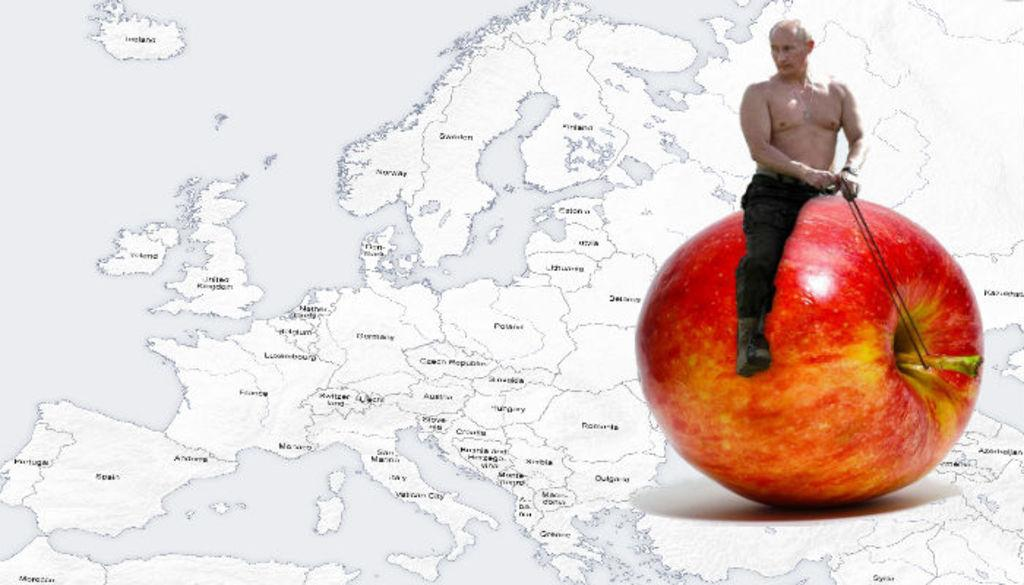Who is present in the image? There is a man in the image. What is the man sitting on? The man is sitting on an apple. What is the man holding in his hands? The man is holding ropes with his hands. What can be seen in the background of the image? There is a world map in the background of the image. Where is the tub located in the image? There is no tub present in the image. What type of battle is depicted in the image? There is no battle depicted in the image; it features a man sitting on an apple and holding ropes. 